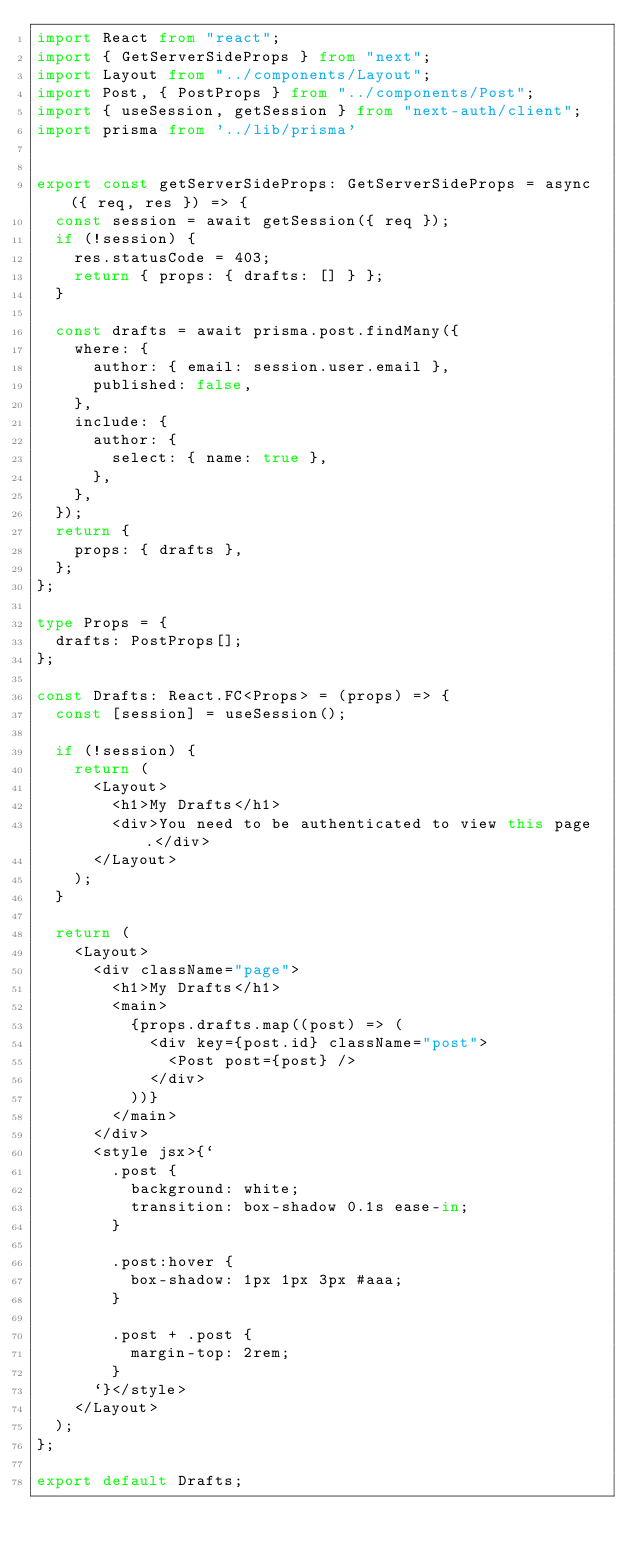<code> <loc_0><loc_0><loc_500><loc_500><_TypeScript_>import React from "react";
import { GetServerSideProps } from "next";
import Layout from "../components/Layout";
import Post, { PostProps } from "../components/Post";
import { useSession, getSession } from "next-auth/client";
import prisma from '../lib/prisma'


export const getServerSideProps: GetServerSideProps = async ({ req, res }) => {
  const session = await getSession({ req });
  if (!session) {
    res.statusCode = 403;
    return { props: { drafts: [] } };
  }

  const drafts = await prisma.post.findMany({
    where: {
      author: { email: session.user.email },
      published: false,
    },
    include: {
      author: {
        select: { name: true },
      },
    },
  });
  return {
    props: { drafts },
  };
};

type Props = {
  drafts: PostProps[];
};

const Drafts: React.FC<Props> = (props) => {
  const [session] = useSession();

  if (!session) {
    return (
      <Layout>
        <h1>My Drafts</h1>
        <div>You need to be authenticated to view this page.</div>
      </Layout>
    );
  }

  return (
    <Layout>
      <div className="page">
        <h1>My Drafts</h1>
        <main>
          {props.drafts.map((post) => (
            <div key={post.id} className="post">
              <Post post={post} />
            </div>
          ))}
        </main>
      </div>
      <style jsx>{`
        .post {
          background: white;
          transition: box-shadow 0.1s ease-in;
        }

        .post:hover {
          box-shadow: 1px 1px 3px #aaa;
        }

        .post + .post {
          margin-top: 2rem;
        }
      `}</style>
    </Layout>
  );
};

export default Drafts;
</code> 